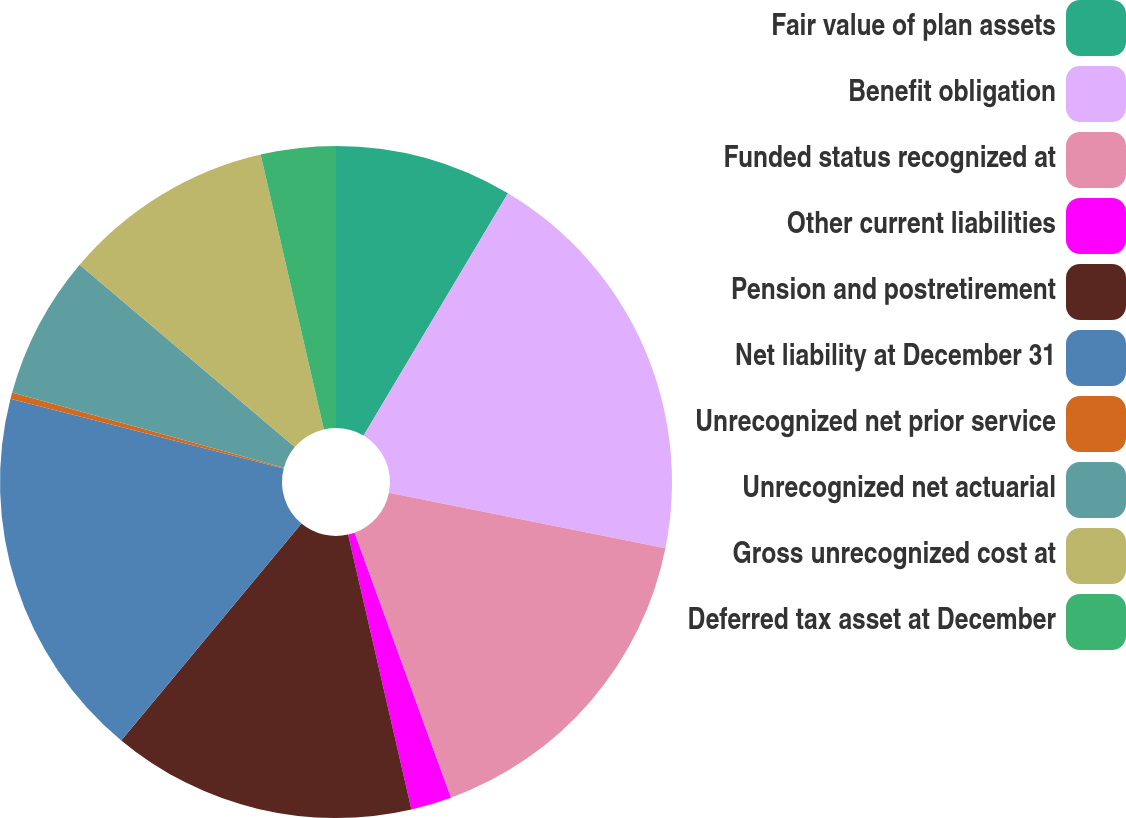<chart> <loc_0><loc_0><loc_500><loc_500><pie_chart><fcel>Fair value of plan assets<fcel>Benefit obligation<fcel>Funded status recognized at<fcel>Other current liabilities<fcel>Pension and postretirement<fcel>Net liability at December 31<fcel>Unrecognized net prior service<fcel>Unrecognized net actuarial<fcel>Gross unrecognized cost at<fcel>Deferred tax asset at December<nl><fcel>8.55%<fcel>19.6%<fcel>16.29%<fcel>1.95%<fcel>14.64%<fcel>17.95%<fcel>0.3%<fcel>6.9%<fcel>10.21%<fcel>3.6%<nl></chart> 